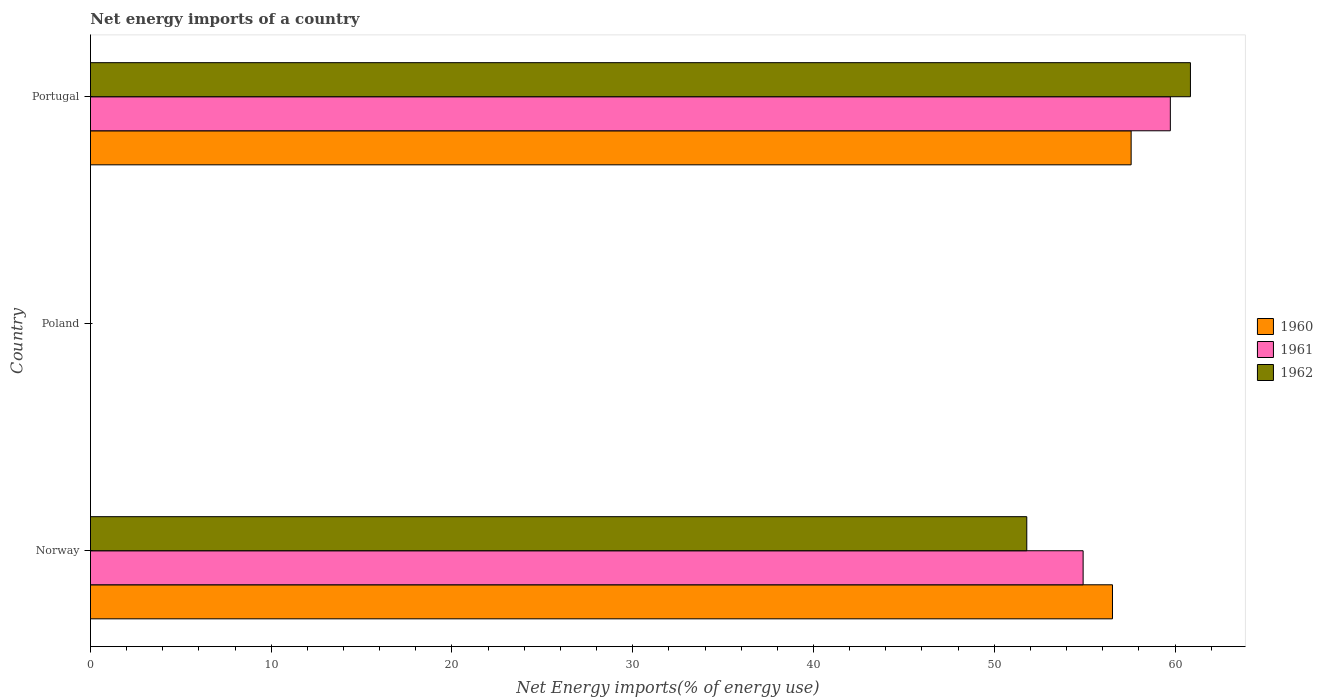Are the number of bars per tick equal to the number of legend labels?
Keep it short and to the point. No. Are the number of bars on each tick of the Y-axis equal?
Make the answer very short. No. How many bars are there on the 1st tick from the top?
Your answer should be very brief. 3. How many bars are there on the 1st tick from the bottom?
Your answer should be compact. 3. In how many cases, is the number of bars for a given country not equal to the number of legend labels?
Provide a succinct answer. 1. What is the net energy imports in 1962 in Poland?
Ensure brevity in your answer.  0. Across all countries, what is the maximum net energy imports in 1960?
Keep it short and to the point. 57.57. What is the total net energy imports in 1962 in the graph?
Offer a very short reply. 112.65. What is the difference between the net energy imports in 1961 in Norway and that in Portugal?
Provide a succinct answer. -4.83. What is the difference between the net energy imports in 1960 in Poland and the net energy imports in 1961 in Norway?
Your answer should be compact. -54.92. What is the average net energy imports in 1960 per country?
Provide a succinct answer. 38.04. What is the difference between the net energy imports in 1961 and net energy imports in 1960 in Norway?
Ensure brevity in your answer.  -1.62. In how many countries, is the net energy imports in 1962 greater than 34 %?
Ensure brevity in your answer.  2. What is the ratio of the net energy imports in 1960 in Norway to that in Portugal?
Provide a short and direct response. 0.98. Is the net energy imports in 1960 in Norway less than that in Portugal?
Make the answer very short. Yes. Is the difference between the net energy imports in 1961 in Norway and Portugal greater than the difference between the net energy imports in 1960 in Norway and Portugal?
Ensure brevity in your answer.  No. What is the difference between the highest and the lowest net energy imports in 1962?
Make the answer very short. 60.85. In how many countries, is the net energy imports in 1960 greater than the average net energy imports in 1960 taken over all countries?
Offer a terse response. 2. Is the sum of the net energy imports in 1962 in Norway and Portugal greater than the maximum net energy imports in 1961 across all countries?
Make the answer very short. Yes. How many bars are there?
Give a very brief answer. 6. What is the difference between two consecutive major ticks on the X-axis?
Your answer should be compact. 10. Does the graph contain any zero values?
Offer a terse response. Yes. Where does the legend appear in the graph?
Provide a short and direct response. Center right. What is the title of the graph?
Offer a terse response. Net energy imports of a country. Does "2008" appear as one of the legend labels in the graph?
Make the answer very short. No. What is the label or title of the X-axis?
Your answer should be very brief. Net Energy imports(% of energy use). What is the Net Energy imports(% of energy use) of 1960 in Norway?
Offer a terse response. 56.54. What is the Net Energy imports(% of energy use) of 1961 in Norway?
Your answer should be compact. 54.92. What is the Net Energy imports(% of energy use) in 1962 in Norway?
Your answer should be very brief. 51.8. What is the Net Energy imports(% of energy use) of 1960 in Poland?
Your answer should be compact. 0. What is the Net Energy imports(% of energy use) in 1961 in Poland?
Offer a terse response. 0. What is the Net Energy imports(% of energy use) of 1960 in Portugal?
Give a very brief answer. 57.57. What is the Net Energy imports(% of energy use) in 1961 in Portugal?
Ensure brevity in your answer.  59.74. What is the Net Energy imports(% of energy use) in 1962 in Portugal?
Provide a succinct answer. 60.85. Across all countries, what is the maximum Net Energy imports(% of energy use) in 1960?
Offer a very short reply. 57.57. Across all countries, what is the maximum Net Energy imports(% of energy use) in 1961?
Offer a terse response. 59.74. Across all countries, what is the maximum Net Energy imports(% of energy use) of 1962?
Make the answer very short. 60.85. Across all countries, what is the minimum Net Energy imports(% of energy use) of 1962?
Your response must be concise. 0. What is the total Net Energy imports(% of energy use) in 1960 in the graph?
Ensure brevity in your answer.  114.12. What is the total Net Energy imports(% of energy use) of 1961 in the graph?
Your response must be concise. 114.66. What is the total Net Energy imports(% of energy use) in 1962 in the graph?
Your answer should be compact. 112.65. What is the difference between the Net Energy imports(% of energy use) of 1960 in Norway and that in Portugal?
Your response must be concise. -1.03. What is the difference between the Net Energy imports(% of energy use) in 1961 in Norway and that in Portugal?
Offer a terse response. -4.83. What is the difference between the Net Energy imports(% of energy use) in 1962 in Norway and that in Portugal?
Your answer should be compact. -9.05. What is the difference between the Net Energy imports(% of energy use) of 1960 in Norway and the Net Energy imports(% of energy use) of 1961 in Portugal?
Provide a short and direct response. -3.2. What is the difference between the Net Energy imports(% of energy use) of 1960 in Norway and the Net Energy imports(% of energy use) of 1962 in Portugal?
Provide a short and direct response. -4.31. What is the difference between the Net Energy imports(% of energy use) in 1961 in Norway and the Net Energy imports(% of energy use) in 1962 in Portugal?
Keep it short and to the point. -5.94. What is the average Net Energy imports(% of energy use) in 1960 per country?
Offer a terse response. 38.04. What is the average Net Energy imports(% of energy use) in 1961 per country?
Keep it short and to the point. 38.22. What is the average Net Energy imports(% of energy use) in 1962 per country?
Ensure brevity in your answer.  37.55. What is the difference between the Net Energy imports(% of energy use) of 1960 and Net Energy imports(% of energy use) of 1961 in Norway?
Offer a very short reply. 1.62. What is the difference between the Net Energy imports(% of energy use) of 1960 and Net Energy imports(% of energy use) of 1962 in Norway?
Offer a terse response. 4.74. What is the difference between the Net Energy imports(% of energy use) in 1961 and Net Energy imports(% of energy use) in 1962 in Norway?
Your response must be concise. 3.12. What is the difference between the Net Energy imports(% of energy use) in 1960 and Net Energy imports(% of energy use) in 1961 in Portugal?
Keep it short and to the point. -2.17. What is the difference between the Net Energy imports(% of energy use) of 1960 and Net Energy imports(% of energy use) of 1962 in Portugal?
Give a very brief answer. -3.28. What is the difference between the Net Energy imports(% of energy use) of 1961 and Net Energy imports(% of energy use) of 1962 in Portugal?
Give a very brief answer. -1.11. What is the ratio of the Net Energy imports(% of energy use) in 1960 in Norway to that in Portugal?
Offer a terse response. 0.98. What is the ratio of the Net Energy imports(% of energy use) in 1961 in Norway to that in Portugal?
Offer a terse response. 0.92. What is the ratio of the Net Energy imports(% of energy use) in 1962 in Norway to that in Portugal?
Provide a short and direct response. 0.85. What is the difference between the highest and the lowest Net Energy imports(% of energy use) of 1960?
Ensure brevity in your answer.  57.57. What is the difference between the highest and the lowest Net Energy imports(% of energy use) in 1961?
Offer a very short reply. 59.74. What is the difference between the highest and the lowest Net Energy imports(% of energy use) of 1962?
Your answer should be compact. 60.85. 